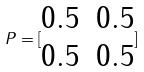<formula> <loc_0><loc_0><loc_500><loc_500>P = [ \begin{matrix} 0 . 5 & 0 . 5 \\ 0 . 5 & 0 . 5 \\ \end{matrix} ]</formula> 